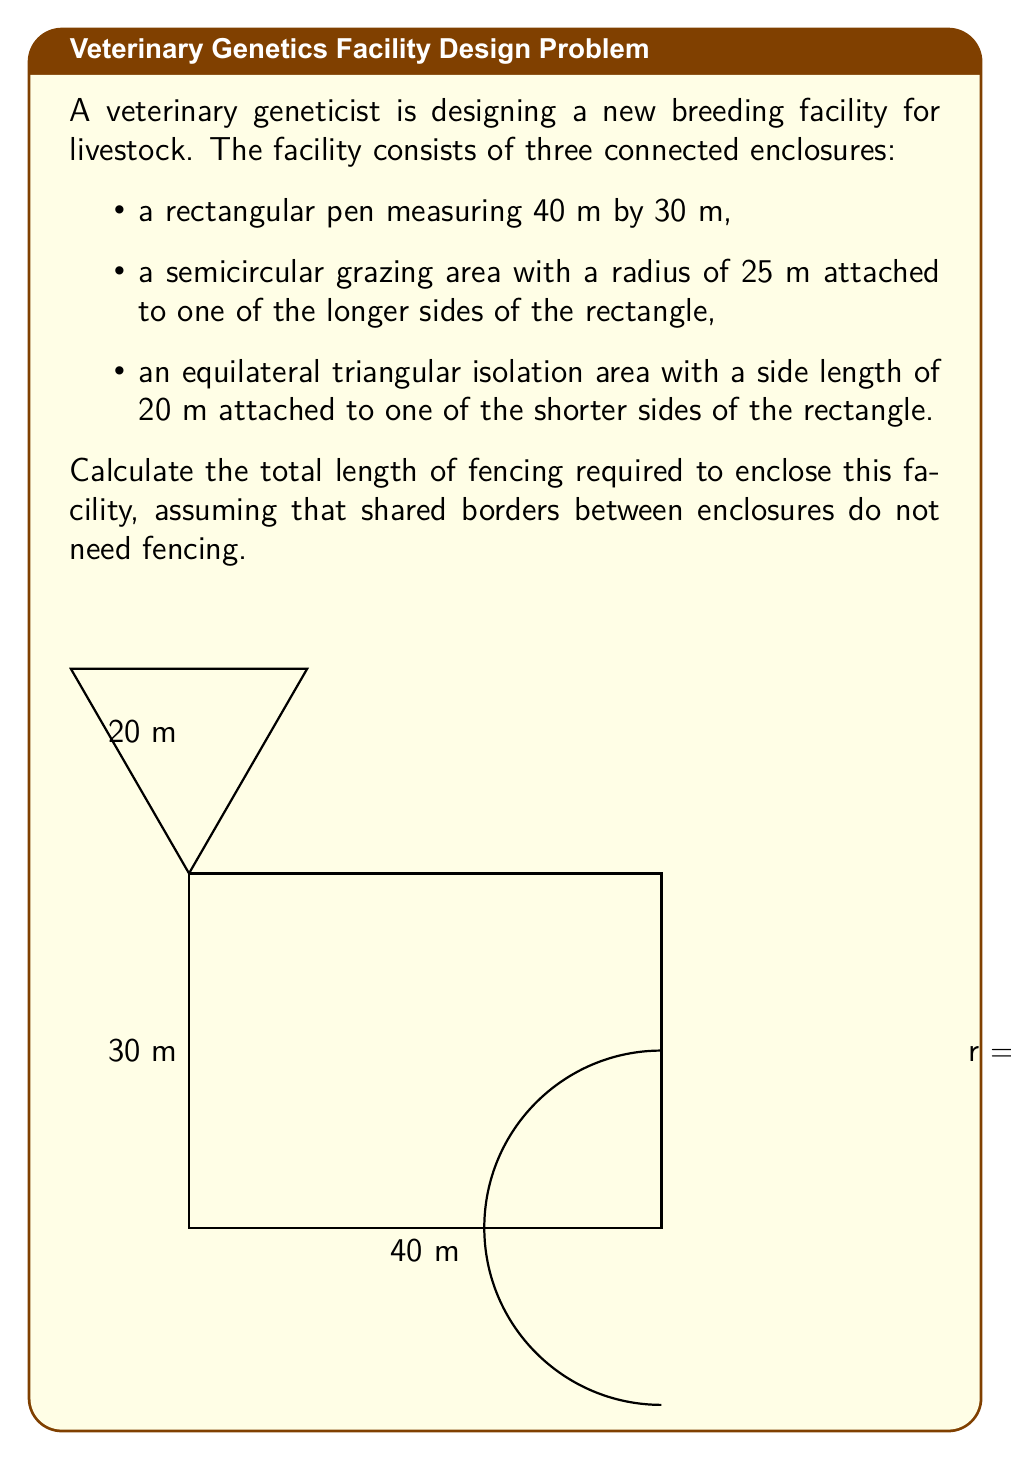Help me with this question. Let's break this problem down into steps:

1) First, we need to calculate the perimeter of each shape, excluding the shared borders:

   a) Rectangle: We only need three sides, as one long side is shared with the semicircle.
      Perimeter of rectangle = $40 + 30 + 30 = 100$ m

   b) Semicircle: We need the curved part of the semicircle.
      Circumference of a full circle = $2\pi r$
      For a semicircle, we need half of this: $\pi r$
      Perimeter of semicircle = $\pi \cdot 25 = 25\pi$ m

   c) Equilateral Triangle: We need two sides, as one side is shared with the rectangle.
      Perimeter of triangle = $20 + 20 = 40$ m

2) Now, we sum up all these parts:

   Total fencing = Rectangle + Semicircle + Triangle
                 = $100 + 25\pi + 40$
                 = $140 + 25\pi$ m

3) To get a numerical value, we can use $\pi \approx 3.14159$:

   Total fencing ≈ $140 + 25 \cdot 3.14159$
                 ≈ $140 + 78.54$
                 ≈ $218.54$ m

Therefore, the total length of fencing required is approximately 218.54 meters.
Answer: $140 + 25\pi$ m (≈ 218.54 m) 